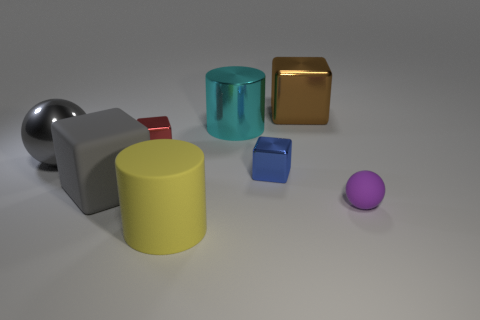What number of things are either balls that are on the right side of the big brown metal cube or tiny gray objects?
Keep it short and to the point. 1. There is a cylinder that is behind the matte ball; what is it made of?
Make the answer very short. Metal. What is the material of the large yellow object?
Make the answer very short. Rubber. What is the material of the small cube that is in front of the gray sphere that is behind the matte object that is to the right of the big brown block?
Keep it short and to the point. Metal. There is a yellow rubber cylinder; is it the same size as the sphere on the left side of the small sphere?
Make the answer very short. Yes. How many objects are big metal objects that are left of the brown metal object or big blocks on the right side of the cyan cylinder?
Provide a succinct answer. 3. What is the color of the big block that is left of the matte cylinder?
Keep it short and to the point. Gray. There is a blue thing that is on the right side of the metal cylinder; is there a shiny thing behind it?
Offer a terse response. Yes. Is the number of tiny rubber balls less than the number of tiny brown cubes?
Make the answer very short. No. What is the material of the big gray thing right of the metallic thing to the left of the big gray cube?
Offer a very short reply. Rubber. 